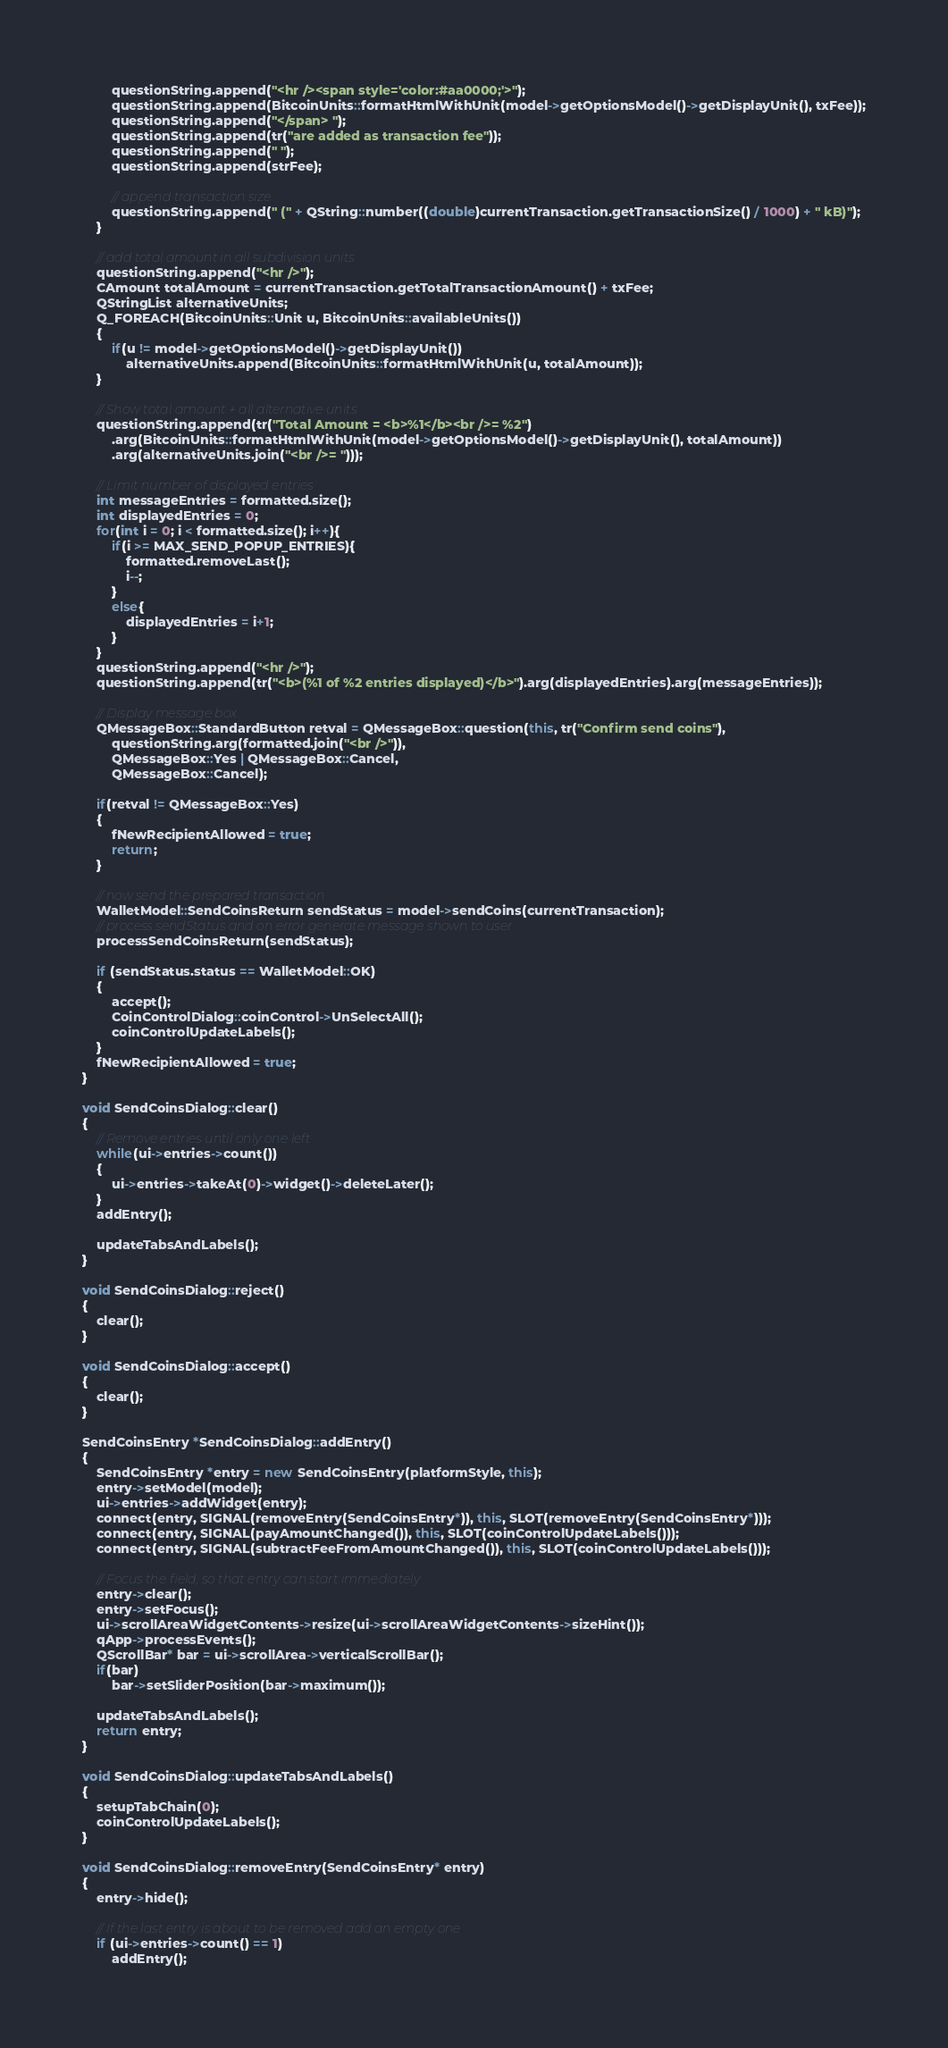<code> <loc_0><loc_0><loc_500><loc_500><_C++_>        questionString.append("<hr /><span style='color:#aa0000;'>");
        questionString.append(BitcoinUnits::formatHtmlWithUnit(model->getOptionsModel()->getDisplayUnit(), txFee));
        questionString.append("</span> ");
        questionString.append(tr("are added as transaction fee"));
        questionString.append(" ");
        questionString.append(strFee);

        // append transaction size
        questionString.append(" (" + QString::number((double)currentTransaction.getTransactionSize() / 1000) + " kB)");
    }

    // add total amount in all subdivision units
    questionString.append("<hr />");
    CAmount totalAmount = currentTransaction.getTotalTransactionAmount() + txFee;
    QStringList alternativeUnits;
    Q_FOREACH(BitcoinUnits::Unit u, BitcoinUnits::availableUnits())
    {
        if(u != model->getOptionsModel()->getDisplayUnit())
            alternativeUnits.append(BitcoinUnits::formatHtmlWithUnit(u, totalAmount));
    }

    // Show total amount + all alternative units
    questionString.append(tr("Total Amount = <b>%1</b><br />= %2")
        .arg(BitcoinUnits::formatHtmlWithUnit(model->getOptionsModel()->getDisplayUnit(), totalAmount))
        .arg(alternativeUnits.join("<br />= ")));

    // Limit number of displayed entries
    int messageEntries = formatted.size();
    int displayedEntries = 0;
    for(int i = 0; i < formatted.size(); i++){
        if(i >= MAX_SEND_POPUP_ENTRIES){
            formatted.removeLast();
            i--;
        }
        else{
            displayedEntries = i+1;
        }
    }
    questionString.append("<hr />");
    questionString.append(tr("<b>(%1 of %2 entries displayed)</b>").arg(displayedEntries).arg(messageEntries));

    // Display message box
    QMessageBox::StandardButton retval = QMessageBox::question(this, tr("Confirm send coins"),
        questionString.arg(formatted.join("<br />")),
        QMessageBox::Yes | QMessageBox::Cancel,
        QMessageBox::Cancel);

    if(retval != QMessageBox::Yes)
    {
        fNewRecipientAllowed = true;
        return;
    }

    // now send the prepared transaction
    WalletModel::SendCoinsReturn sendStatus = model->sendCoins(currentTransaction);
    // process sendStatus and on error generate message shown to user
    processSendCoinsReturn(sendStatus);

    if (sendStatus.status == WalletModel::OK)
    {
        accept();
        CoinControlDialog::coinControl->UnSelectAll();
        coinControlUpdateLabels();
    }
    fNewRecipientAllowed = true;
}

void SendCoinsDialog::clear()
{
    // Remove entries until only one left
    while(ui->entries->count())
    {
        ui->entries->takeAt(0)->widget()->deleteLater();
    }
    addEntry();

    updateTabsAndLabels();
}

void SendCoinsDialog::reject()
{
    clear();
}

void SendCoinsDialog::accept()
{
    clear();
}

SendCoinsEntry *SendCoinsDialog::addEntry()
{
    SendCoinsEntry *entry = new SendCoinsEntry(platformStyle, this);
    entry->setModel(model);
    ui->entries->addWidget(entry);
    connect(entry, SIGNAL(removeEntry(SendCoinsEntry*)), this, SLOT(removeEntry(SendCoinsEntry*)));
    connect(entry, SIGNAL(payAmountChanged()), this, SLOT(coinControlUpdateLabels()));
    connect(entry, SIGNAL(subtractFeeFromAmountChanged()), this, SLOT(coinControlUpdateLabels()));

    // Focus the field, so that entry can start immediately
    entry->clear();
    entry->setFocus();
    ui->scrollAreaWidgetContents->resize(ui->scrollAreaWidgetContents->sizeHint());
    qApp->processEvents();
    QScrollBar* bar = ui->scrollArea->verticalScrollBar();
    if(bar)
        bar->setSliderPosition(bar->maximum());

    updateTabsAndLabels();
    return entry;
}

void SendCoinsDialog::updateTabsAndLabels()
{
    setupTabChain(0);
    coinControlUpdateLabels();
}

void SendCoinsDialog::removeEntry(SendCoinsEntry* entry)
{
    entry->hide();

    // If the last entry is about to be removed add an empty one
    if (ui->entries->count() == 1)
        addEntry();
</code> 